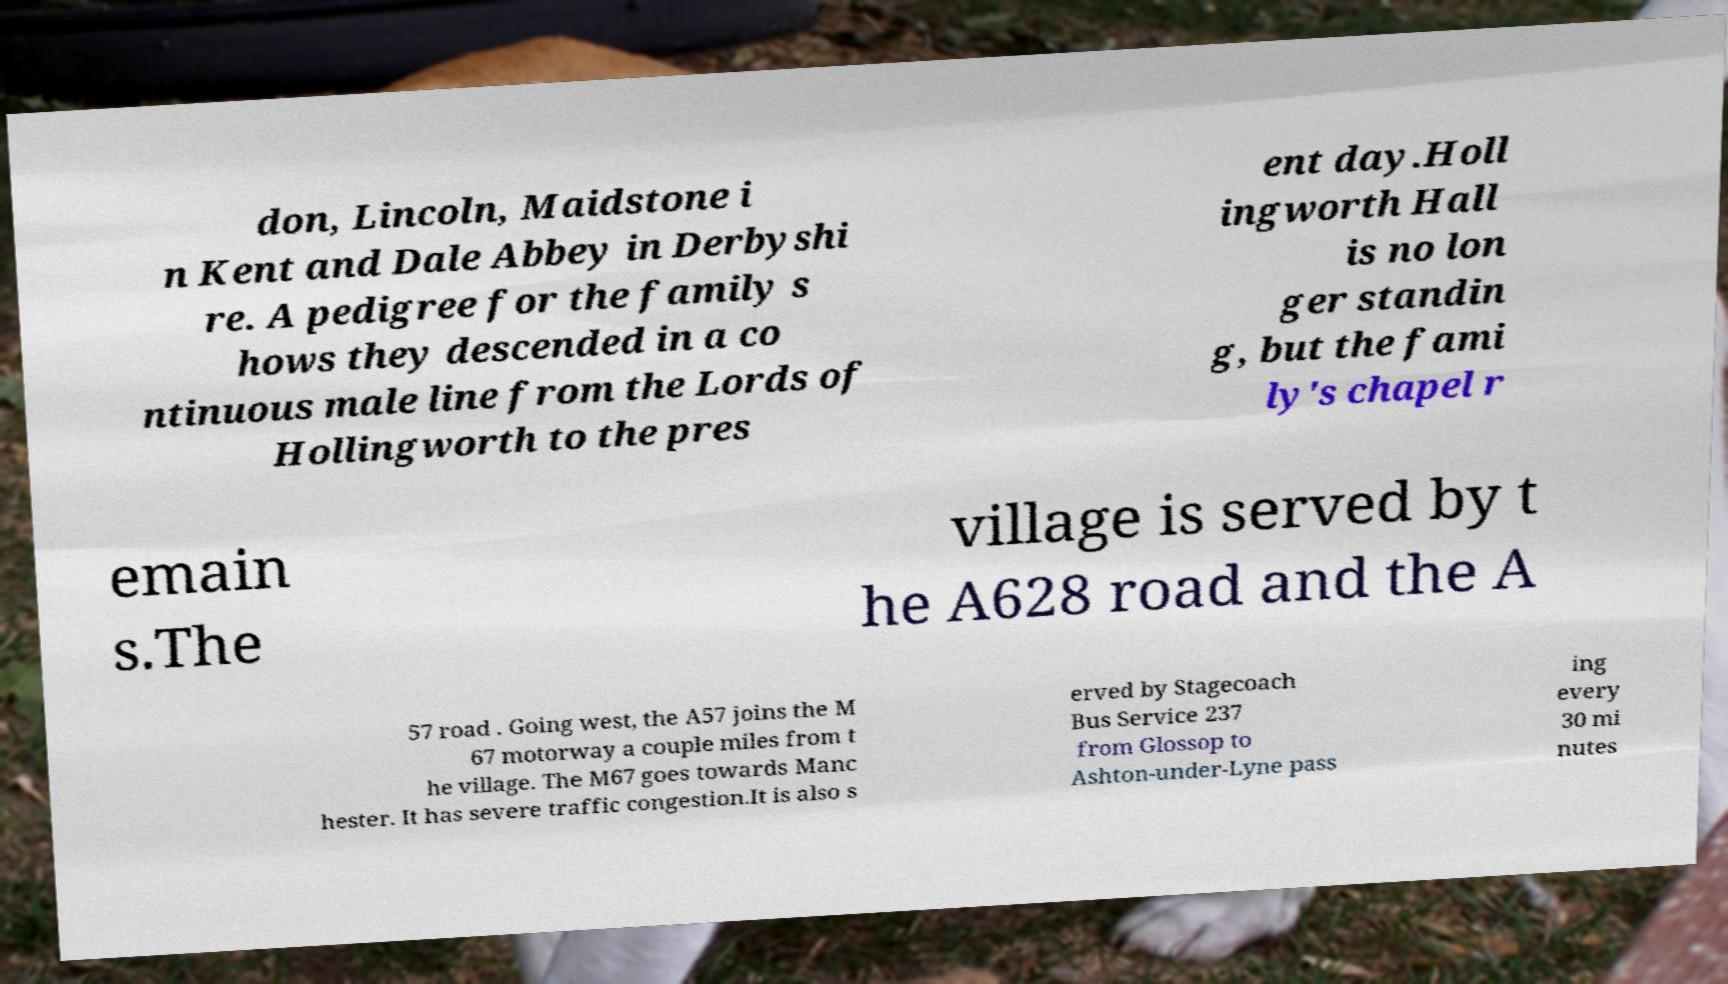Could you extract and type out the text from this image? don, Lincoln, Maidstone i n Kent and Dale Abbey in Derbyshi re. A pedigree for the family s hows they descended in a co ntinuous male line from the Lords of Hollingworth to the pres ent day.Holl ingworth Hall is no lon ger standin g, but the fami ly's chapel r emain s.The village is served by t he A628 road and the A 57 road . Going west, the A57 joins the M 67 motorway a couple miles from t he village. The M67 goes towards Manc hester. It has severe traffic congestion.It is also s erved by Stagecoach Bus Service 237 from Glossop to Ashton-under-Lyne pass ing every 30 mi nutes 